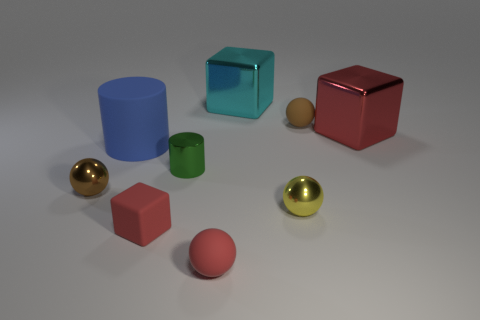How many yellow shiny balls are the same size as the metallic cylinder?
Make the answer very short. 1. Are there an equal number of large metallic blocks that are in front of the red shiny block and things in front of the tiny yellow metal thing?
Ensure brevity in your answer.  No. Does the blue cylinder have the same material as the cyan block?
Offer a very short reply. No. There is a small matte thing to the left of the small red rubber sphere; is there a metal cylinder that is left of it?
Your answer should be compact. No. Are there any rubber things of the same shape as the tiny brown metal thing?
Offer a very short reply. Yes. Is the tiny cylinder the same color as the rubber cylinder?
Offer a terse response. No. What material is the tiny sphere that is behind the brown object that is on the left side of the tiny shiny cylinder?
Your answer should be compact. Rubber. The blue matte object has what size?
Your response must be concise. Large. What size is the red cube that is the same material as the red ball?
Provide a short and direct response. Small. There is a metal ball that is left of the yellow metal object; does it have the same size as the big red metal thing?
Provide a short and direct response. No. 